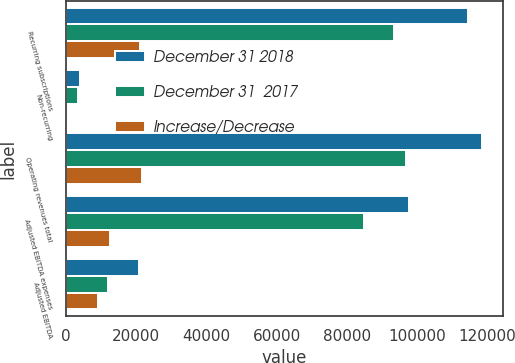<chart> <loc_0><loc_0><loc_500><loc_500><stacked_bar_chart><ecel><fcel>Recurring subscriptions<fcel>Non-recurring<fcel>Operating revenues total<fcel>Adjusted EBITDA expenses<fcel>Adjusted EBITDA<nl><fcel>December 31 2018<fcel>114590<fcel>3980<fcel>118570<fcel>97635<fcel>20935<nl><fcel>December 31  2017<fcel>93481<fcel>3463<fcel>96944<fcel>85052<fcel>11892<nl><fcel>Increase/Decrease<fcel>21109<fcel>517<fcel>21626<fcel>12583<fcel>9043<nl></chart> 